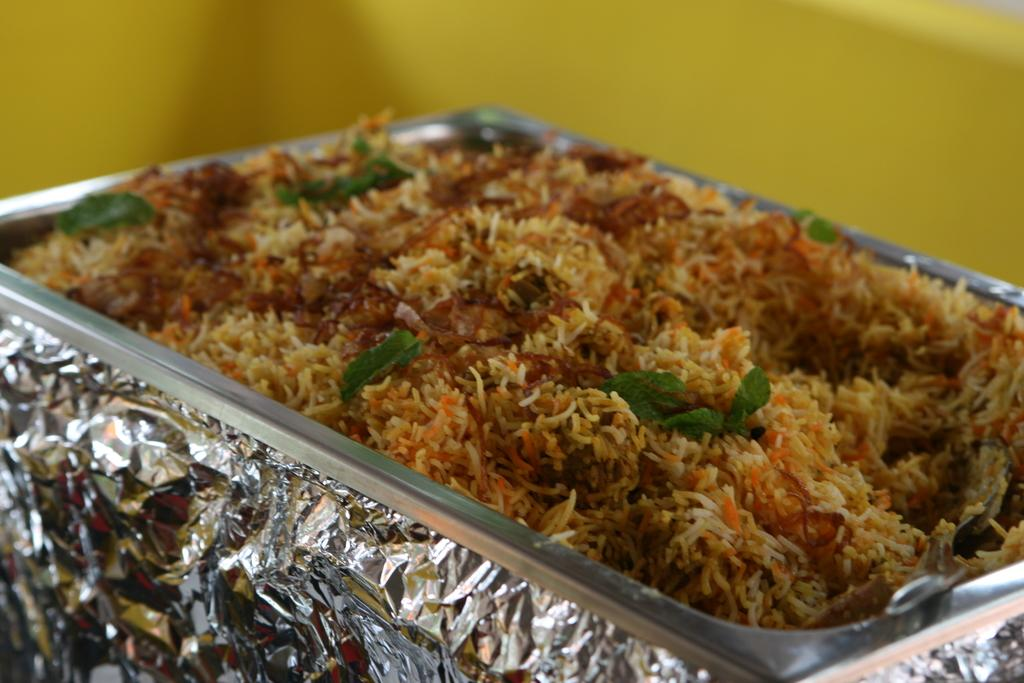What is in the bowl that is visible in the image? There is a bowl in the image, and it contains rice. Is there anything else present at the bottom of the bowl? Yes, there is a silver foil at the bottom of the bowl. What type of plastic control can be seen in the image? There is no plastic control present in the image. 